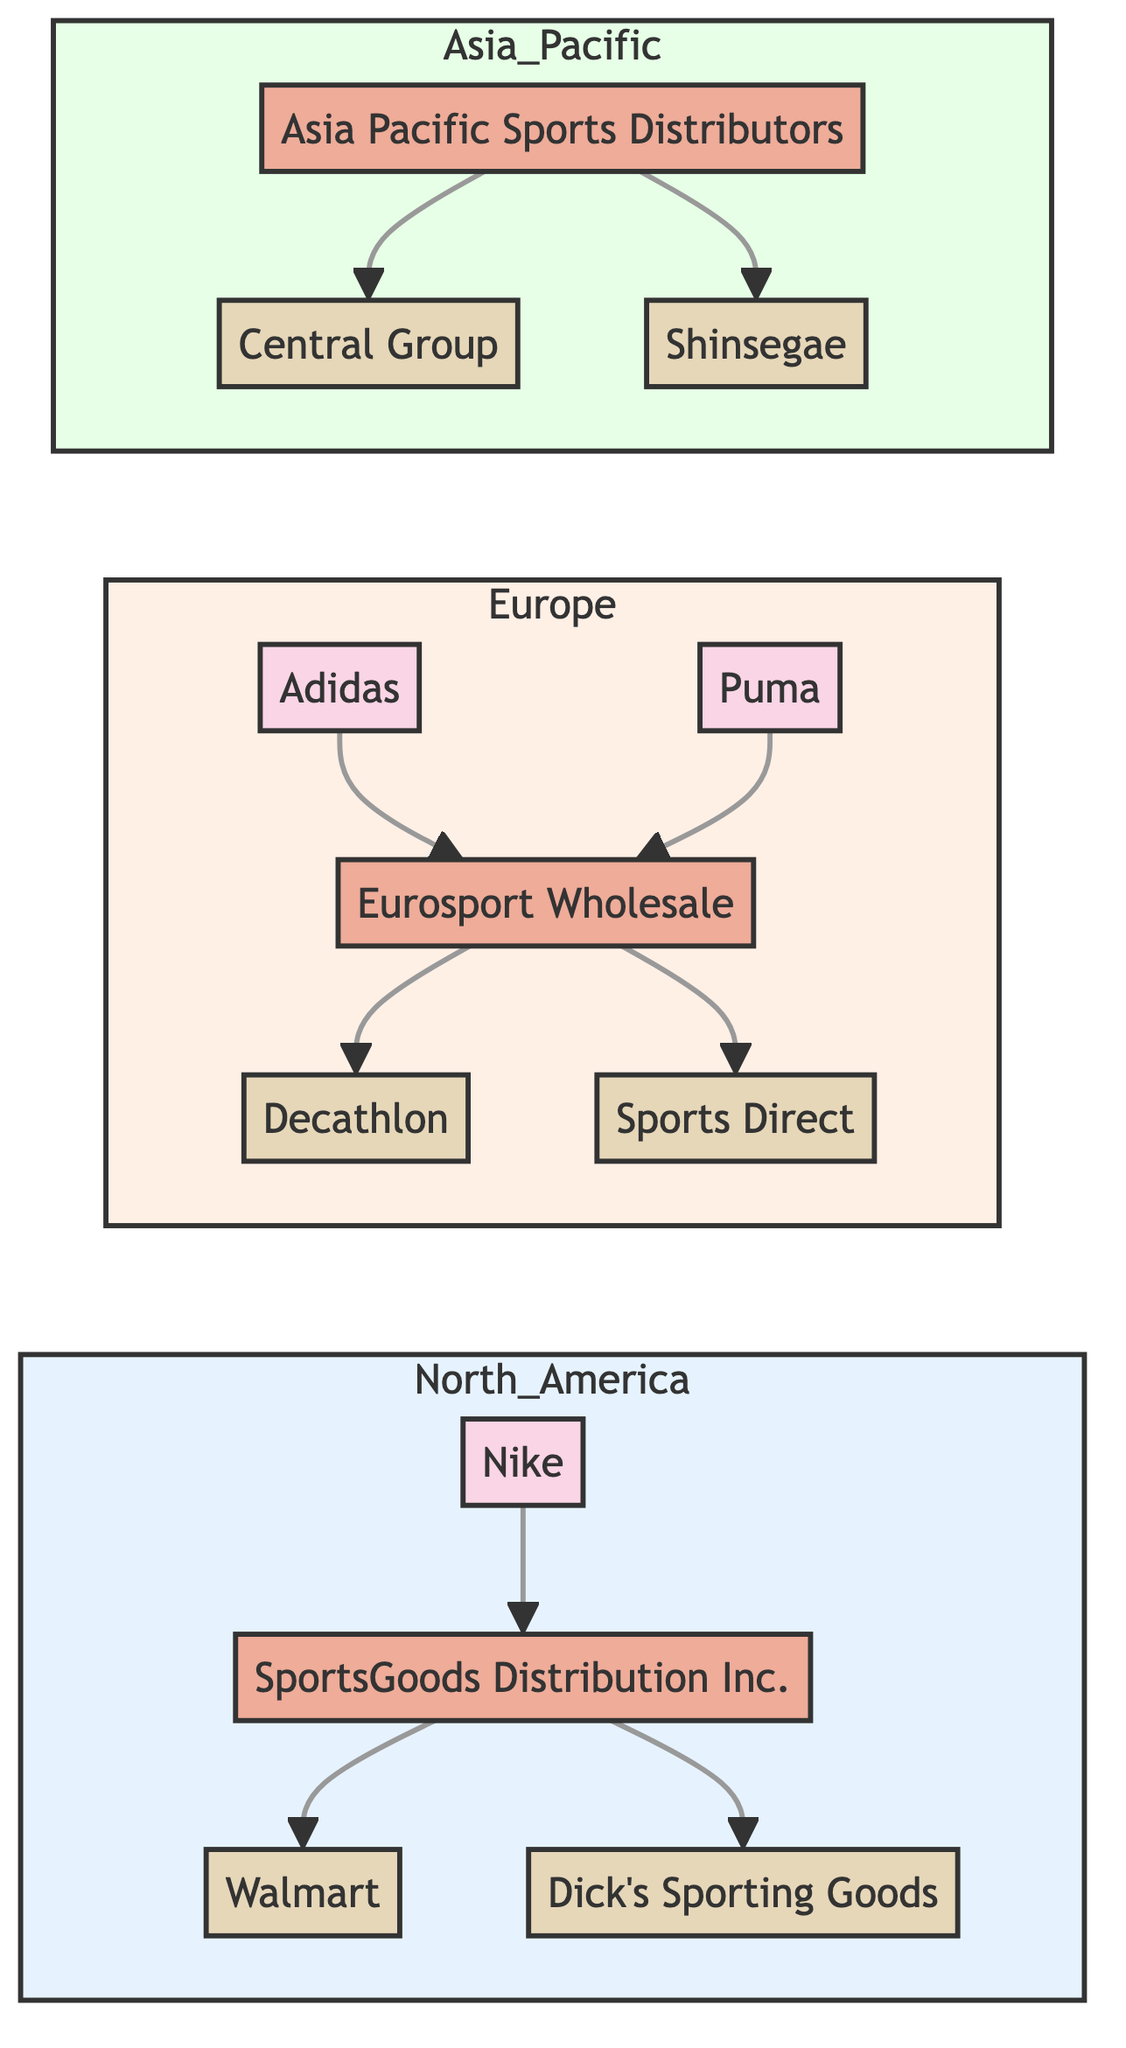What manufacturers are located in North America? In the North America subgraph, the only manufacturer listed is Nike. Therefore, the response identifies Nike as the manufacturer in that region.
Answer: Nike Who is the distributor connected to Adidas? In the Europe subgraph, the only distributor connected to Adidas is Eurosport Wholesale. The question seeks the specific distributor associated with Adidas.
Answer: Eurosport Wholesale How many retailers are there in Europe? In the Europe subgraph, there are two retailers: Decathlon and Sports Direct. Therefore, the count of retailers in that region totals two.
Answer: 2 Which products does Walmart offer? Referring to the North America subgraph connected to Walmart, the retailer offers Footwear and Apparel. The products are directly linked to Walmart in the retailer's listing.
Answer: Footwear, Apparel What is the relationship between Puma and Sports Direct? The flow from Puma leads to the Eurosport distributor, which in turn connects to Sports Direct. Thus, Puma's relationship with Sports Direct is indirect, facilitated through Eurosport Wholesale.
Answer: Indirect via Eurosport Which region has two distributors listed? Analyzing the provided data, the North America region only shows one distributor (SportsGoods Distribution Inc.), while Europe has one (Eurosport Wholesale). The Asia Pacific region also lists only one (Asia Pacific Sports Distributors). Therefore, no region has two distributors; the answer checks for the count.
Answer: None What products are offered by Shinsegae? In the Asia Pacific subgraph, Shinsegae is directly linked and is shown to provide Equipment and Accessories. This aligns with the detailed description.
Answer: Equipment, Accessories Which region connects Central Group with a distributor? In the Asia Pacific region, Central Group is shown to connect with the Asia Pacific Sports Distributors. The inquiry is for a region that includes this connection.
Answer: Asia Pacific How many manufacturers are located in Europe? In the Europe subgraph, there are two manufacturers listed: Adidas and Puma. Therefore, the count of manufacturers in that region is two.
Answer: 2 